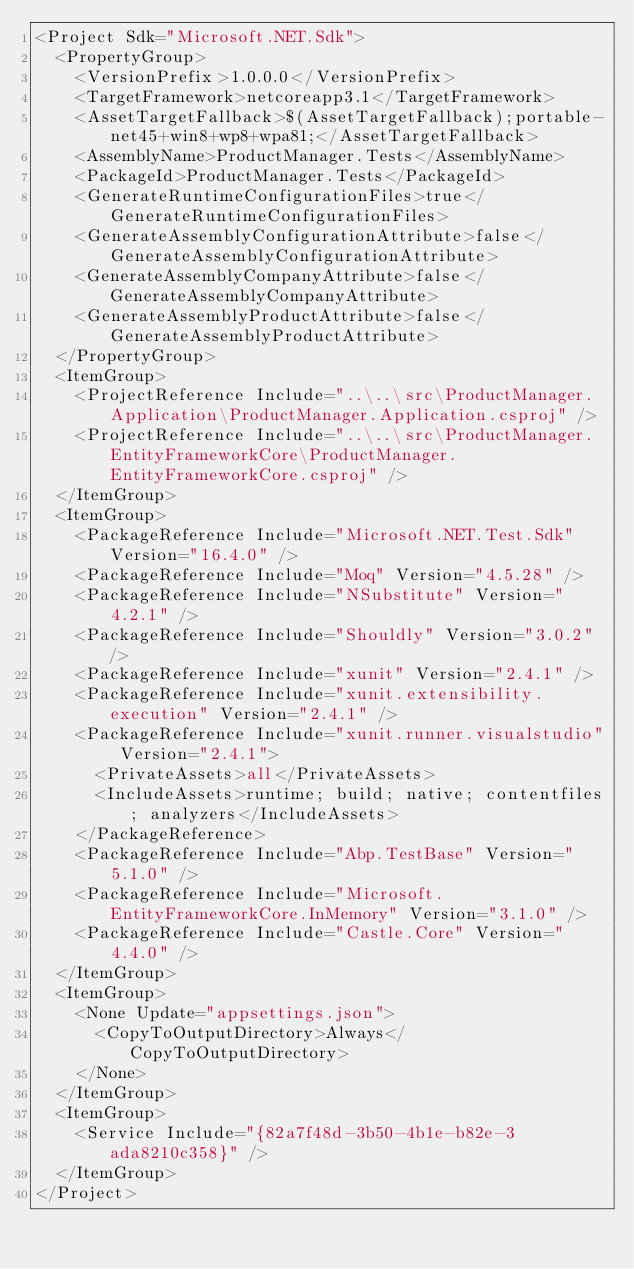<code> <loc_0><loc_0><loc_500><loc_500><_XML_><Project Sdk="Microsoft.NET.Sdk">
  <PropertyGroup>
    <VersionPrefix>1.0.0.0</VersionPrefix>
    <TargetFramework>netcoreapp3.1</TargetFramework>
    <AssetTargetFallback>$(AssetTargetFallback);portable-net45+win8+wp8+wpa81;</AssetTargetFallback>
    <AssemblyName>ProductManager.Tests</AssemblyName>
    <PackageId>ProductManager.Tests</PackageId>
    <GenerateRuntimeConfigurationFiles>true</GenerateRuntimeConfigurationFiles>
    <GenerateAssemblyConfigurationAttribute>false</GenerateAssemblyConfigurationAttribute>
    <GenerateAssemblyCompanyAttribute>false</GenerateAssemblyCompanyAttribute>
    <GenerateAssemblyProductAttribute>false</GenerateAssemblyProductAttribute>
  </PropertyGroup>
  <ItemGroup>
    <ProjectReference Include="..\..\src\ProductManager.Application\ProductManager.Application.csproj" />
    <ProjectReference Include="..\..\src\ProductManager.EntityFrameworkCore\ProductManager.EntityFrameworkCore.csproj" />
  </ItemGroup>
  <ItemGroup>
    <PackageReference Include="Microsoft.NET.Test.Sdk" Version="16.4.0" />
    <PackageReference Include="Moq" Version="4.5.28" />
    <PackageReference Include="NSubstitute" Version="4.2.1" />
    <PackageReference Include="Shouldly" Version="3.0.2" />
    <PackageReference Include="xunit" Version="2.4.1" />
    <PackageReference Include="xunit.extensibility.execution" Version="2.4.1" />
    <PackageReference Include="xunit.runner.visualstudio" Version="2.4.1">
      <PrivateAssets>all</PrivateAssets>
      <IncludeAssets>runtime; build; native; contentfiles; analyzers</IncludeAssets>
    </PackageReference>
    <PackageReference Include="Abp.TestBase" Version="5.1.0" />
    <PackageReference Include="Microsoft.EntityFrameworkCore.InMemory" Version="3.1.0" />
    <PackageReference Include="Castle.Core" Version="4.4.0" />
  </ItemGroup>
  <ItemGroup>
    <None Update="appsettings.json">
      <CopyToOutputDirectory>Always</CopyToOutputDirectory>
    </None>
  </ItemGroup>
  <ItemGroup>
    <Service Include="{82a7f48d-3b50-4b1e-b82e-3ada8210c358}" />
  </ItemGroup>
</Project></code> 